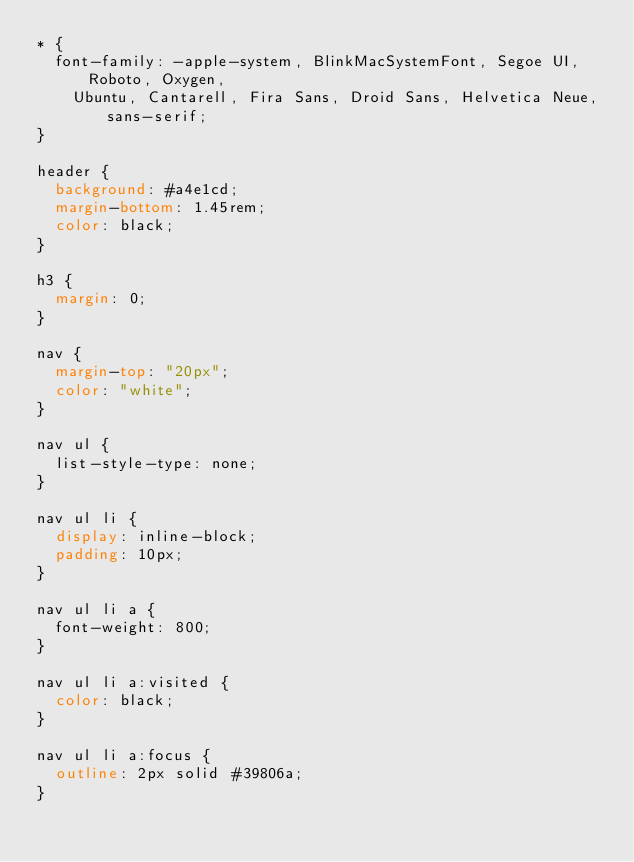<code> <loc_0><loc_0><loc_500><loc_500><_CSS_>* {
  font-family: -apple-system, BlinkMacSystemFont, Segoe UI, Roboto, Oxygen,
    Ubuntu, Cantarell, Fira Sans, Droid Sans, Helvetica Neue, sans-serif;
}

header {
  background: #a4e1cd;
  margin-bottom: 1.45rem;
  color: black;
}

h3 {
  margin: 0;
}

nav {
  margin-top: "20px";
  color: "white";
}

nav ul {
  list-style-type: none;
}

nav ul li {
  display: inline-block;
  padding: 10px;
}

nav ul li a {
  font-weight: 800;
}

nav ul li a:visited {
  color: black;
}

nav ul li a:focus {
  outline: 2px solid #39806a;
}
</code> 